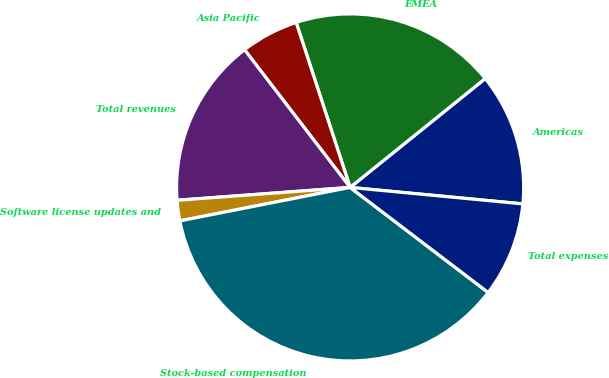<chart> <loc_0><loc_0><loc_500><loc_500><pie_chart><fcel>Americas<fcel>EMEA<fcel>Asia Pacific<fcel>Total revenues<fcel>Software license updates and<fcel>Stock-based compensation<fcel>Total expenses<nl><fcel>12.31%<fcel>19.24%<fcel>5.38%<fcel>15.77%<fcel>1.91%<fcel>36.56%<fcel>8.84%<nl></chart> 